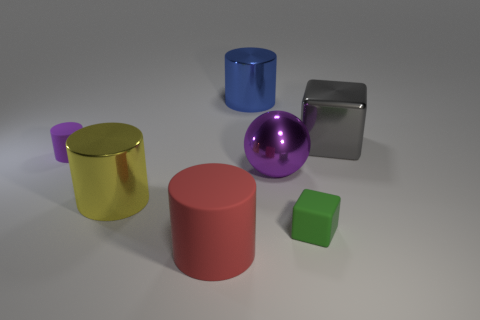Is the color of the small rubber cube the same as the big metallic object on the left side of the large red thing?
Your answer should be very brief. No. Are there the same number of large shiny things behind the yellow cylinder and blue cubes?
Offer a very short reply. No. What number of gray cubes are the same size as the green rubber thing?
Offer a very short reply. 0. There is a tiny rubber object that is the same color as the big sphere; what shape is it?
Keep it short and to the point. Cylinder. Are there any small purple rubber cylinders?
Provide a short and direct response. Yes. There is a big thing that is on the right side of the matte block; does it have the same shape as the object that is in front of the green matte block?
Provide a short and direct response. No. How many big things are red rubber balls or purple matte objects?
Provide a short and direct response. 0. The purple object that is made of the same material as the big blue cylinder is what shape?
Make the answer very short. Sphere. Is the large purple shiny thing the same shape as the big yellow thing?
Provide a short and direct response. No. The small block has what color?
Your response must be concise. Green. 